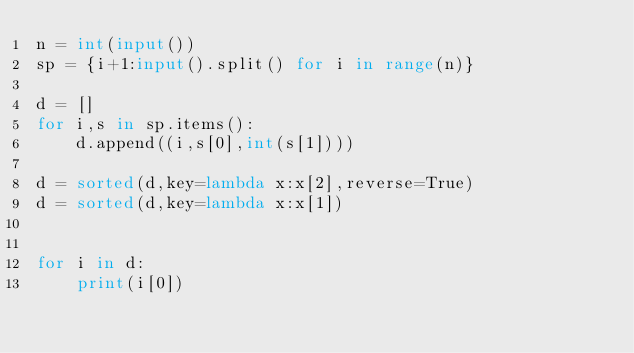Convert code to text. <code><loc_0><loc_0><loc_500><loc_500><_Python_>n = int(input())
sp = {i+1:input().split() for i in range(n)}

d = []
for i,s in sp.items():
    d.append((i,s[0],int(s[1])))
    
d = sorted(d,key=lambda x:x[2],reverse=True)
d = sorted(d,key=lambda x:x[1])
    
    
for i in d:
    print(i[0])
</code> 